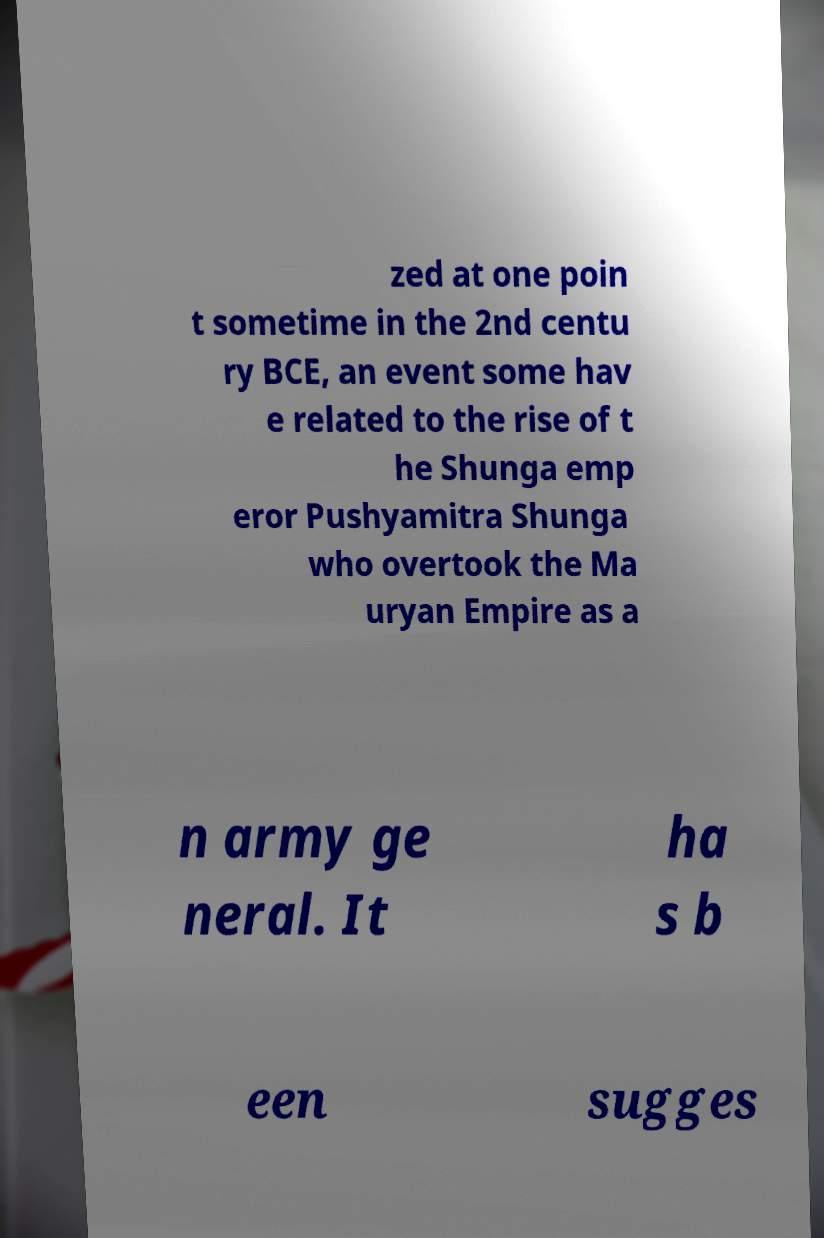Can you read and provide the text displayed in the image?This photo seems to have some interesting text. Can you extract and type it out for me? zed at one poin t sometime in the 2nd centu ry BCE, an event some hav e related to the rise of t he Shunga emp eror Pushyamitra Shunga who overtook the Ma uryan Empire as a n army ge neral. It ha s b een sugges 